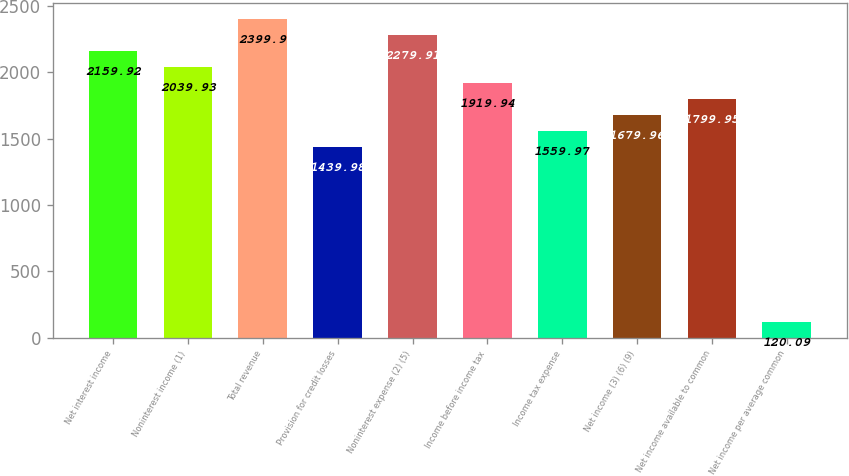<chart> <loc_0><loc_0><loc_500><loc_500><bar_chart><fcel>Net interest income<fcel>Noninterest income (1)<fcel>Total revenue<fcel>Provision for credit losses<fcel>Noninterest expense (2) (5)<fcel>Income before income tax<fcel>Income tax expense<fcel>Net income (3) (6) (9)<fcel>Net income available to common<fcel>Net income per average common<nl><fcel>2159.92<fcel>2039.93<fcel>2399.9<fcel>1439.98<fcel>2279.91<fcel>1919.94<fcel>1559.97<fcel>1679.96<fcel>1799.95<fcel>120.09<nl></chart> 